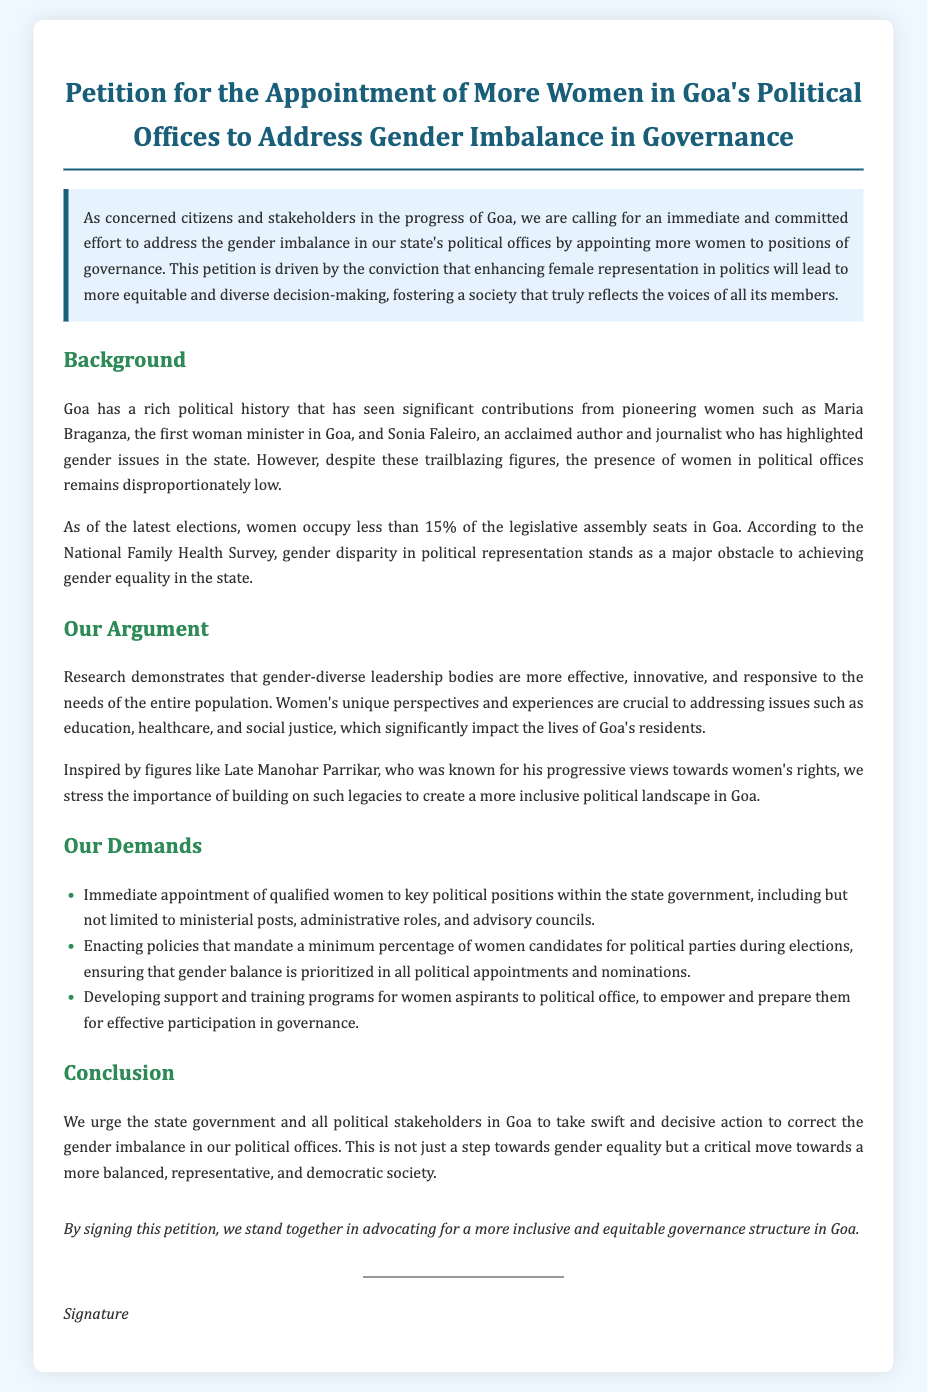What is the title of the petition? The title reflects the main goal of the document, which is for the appointment of more women in political offices in Goa.
Answer: Petition for the Appointment of More Women in Goa's Political Offices to Address Gender Imbalance in Governance Who was the first woman minister in Goa? The document mentions a pioneering figure in Goa's political history relevant to women's representation.
Answer: Maria Braganza What percentage of legislative assembly seats do women occupy in Goa? This statistic illustrates the current gender disparity in political representation in Goa.
Answer: less than 15% What type of programs does the petition demand for women aspirants? This part of the document emphasizes the need for specific initiatives to support women looking to enter politics.
Answer: support and training programs According to the petition, what is a key benefit of gender-diverse leadership? The document presents an argument regarding the positive impacts of having women in leadership roles.
Answer: more effective, innovative, and responsive What is the first demand made in the petition? The list of demands showcases the immediate steps the petitioners wish to see taken regarding women's representation.
Answer: Immediate appointment of qualified women to key political positions Who is mentioned as an inspiration in the context of women's rights? This highlights a significant figure in Goa's political history whose legacy is invoked in the petition.
Answer: Late Manohar Parrikar What does the petition aim to correct? Understanding this point reveals the overall purpose and intention behind the document's creation.
Answer: gender imbalance in our political offices 